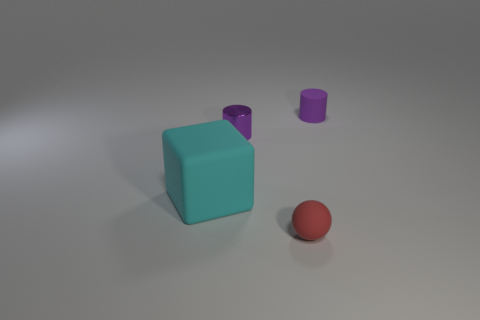What is the size of the other cylinder that is the same color as the tiny matte cylinder?
Offer a very short reply. Small. There is a cylinder that is the same color as the tiny metal thing; what is it made of?
Give a very brief answer. Rubber. Is the shape of the small purple metal thing the same as the small purple matte object?
Make the answer very short. Yes. How big is the rubber object in front of the big cyan matte block?
Provide a short and direct response. Small. Is there a small matte object of the same color as the tiny metallic cylinder?
Keep it short and to the point. Yes. There is a purple cylinder on the right side of the shiny cylinder; is it the same size as the cyan rubber cube?
Make the answer very short. No. What is the color of the big block?
Give a very brief answer. Cyan. What color is the small thing that is in front of the purple thing that is in front of the purple rubber cylinder?
Provide a succinct answer. Red. Are there any brown cylinders that have the same material as the red object?
Make the answer very short. No. What material is the small thing that is to the left of the tiny rubber thing left of the purple matte thing?
Your answer should be compact. Metal. 